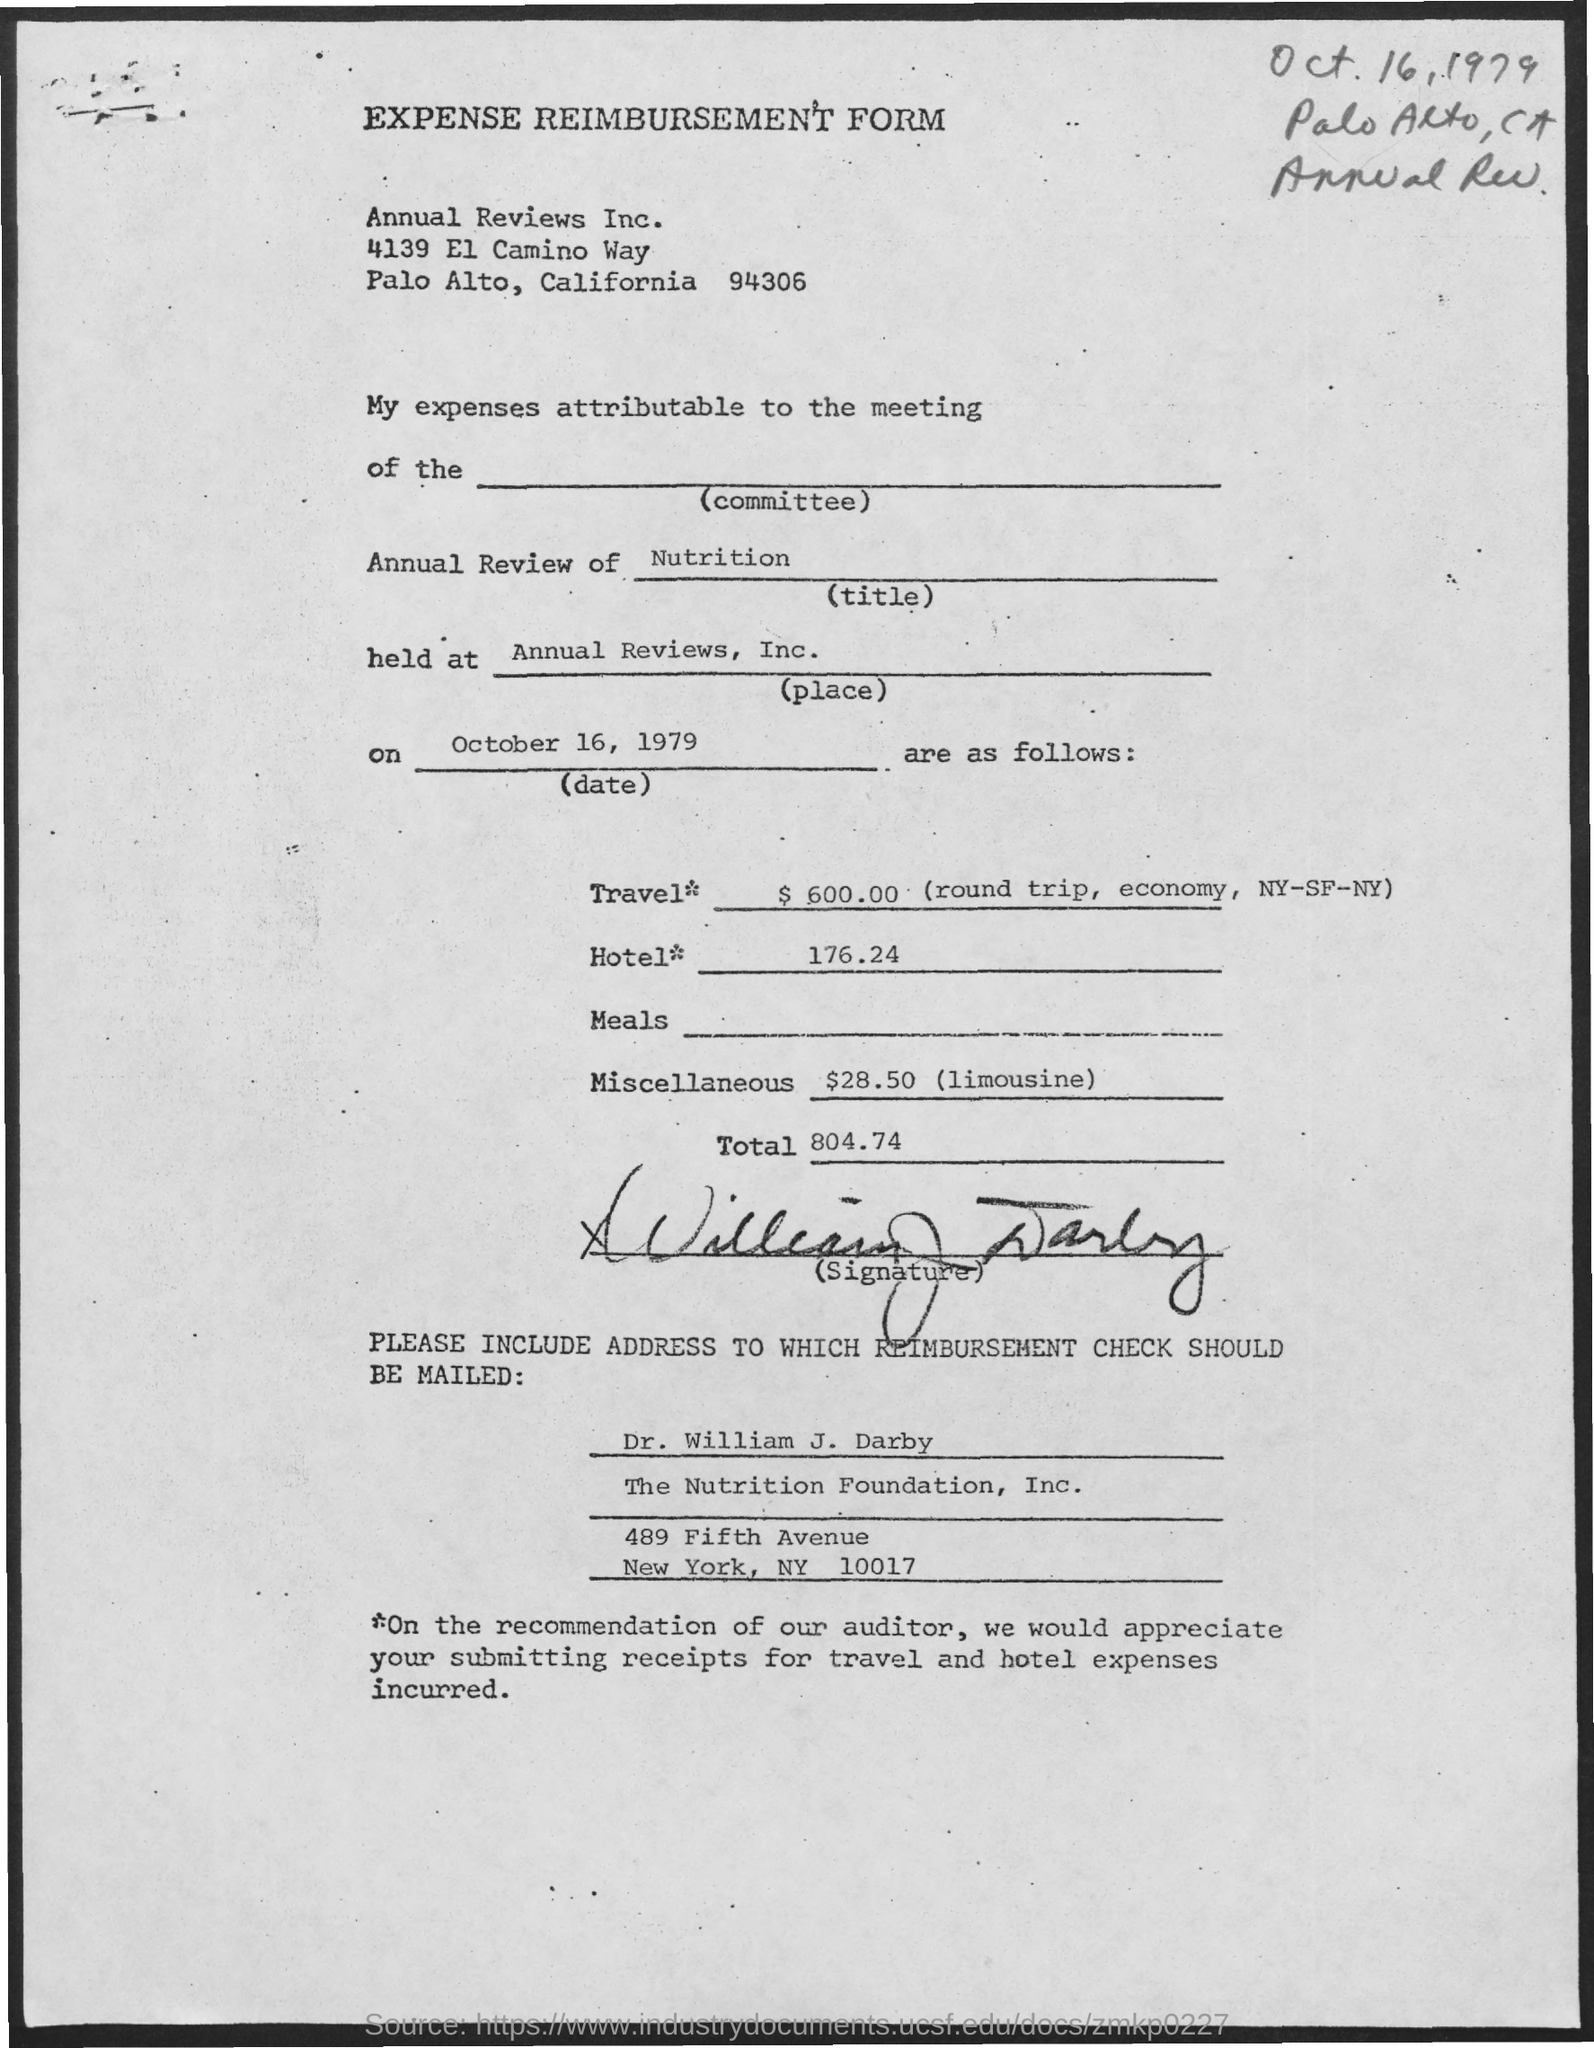How much Travel Expenses ?
Ensure brevity in your answer.  $ 600.00. What is written in the Annual Review Field ?
Your answer should be compact. Nutrition. How much total Hotel Amount ?
Your response must be concise. 176.24. 